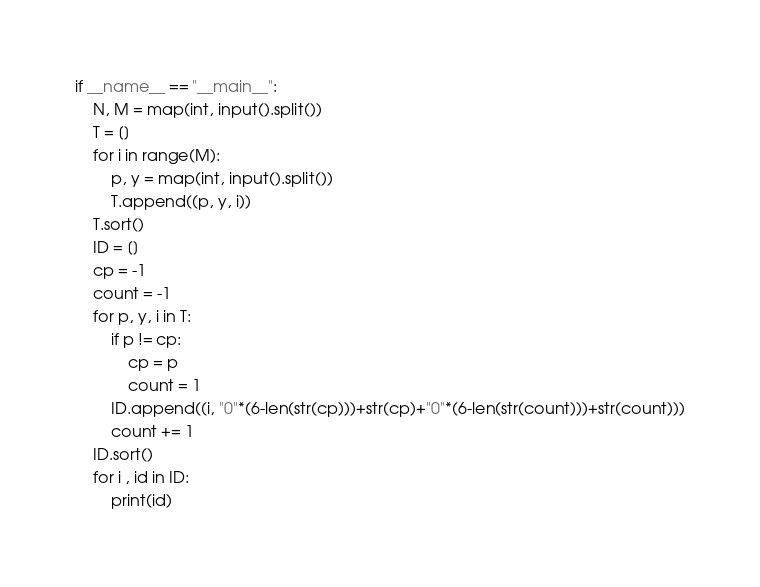Convert code to text. <code><loc_0><loc_0><loc_500><loc_500><_Python_>if __name__ == "__main__":
    N, M = map(int, input().split())
    T = []
    for i in range(M):
        p, y = map(int, input().split())
        T.append((p, y, i))
    T.sort()
    ID = []
    cp = -1
    count = -1
    for p, y, i in T:
        if p != cp:
            cp = p
            count = 1
        ID.append((i, "0"*(6-len(str(cp)))+str(cp)+"0"*(6-len(str(count)))+str(count)))
        count += 1
    ID.sort()
    for i , id in ID:
        print(id)
</code> 